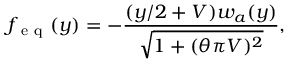Convert formula to latex. <formula><loc_0><loc_0><loc_500><loc_500>f _ { e q } ( y ) = - \frac { ( y / 2 + V ) w _ { a } ( y ) } { \sqrt { 1 + ( \theta \pi V ) ^ { 2 } } } ,</formula> 